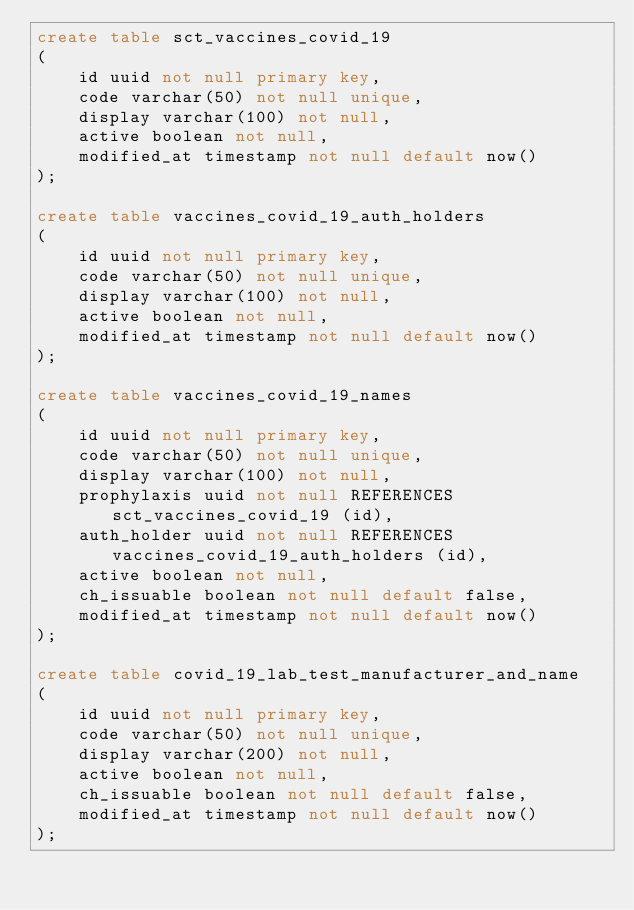Convert code to text. <code><loc_0><loc_0><loc_500><loc_500><_SQL_>create table sct_vaccines_covid_19
(
    id uuid not null primary key,
    code varchar(50) not null unique,
    display varchar(100) not null,
    active boolean not null,
    modified_at timestamp not null default now()
);

create table vaccines_covid_19_auth_holders
(
    id uuid not null primary key,
    code varchar(50) not null unique,
    display varchar(100) not null,
    active boolean not null,
    modified_at timestamp not null default now()
);

create table vaccines_covid_19_names
(
    id uuid not null primary key,
    code varchar(50) not null unique,
    display varchar(100) not null,
    prophylaxis uuid not null REFERENCES sct_vaccines_covid_19 (id),
    auth_holder uuid not null REFERENCES vaccines_covid_19_auth_holders (id),
    active boolean not null,
    ch_issuable boolean not null default false,
    modified_at timestamp not null default now()
);

create table covid_19_lab_test_manufacturer_and_name
(
    id uuid not null primary key,
    code varchar(50) not null unique,
    display varchar(200) not null,
    active boolean not null,
    ch_issuable boolean not null default false,
    modified_at timestamp not null default now()
);</code> 